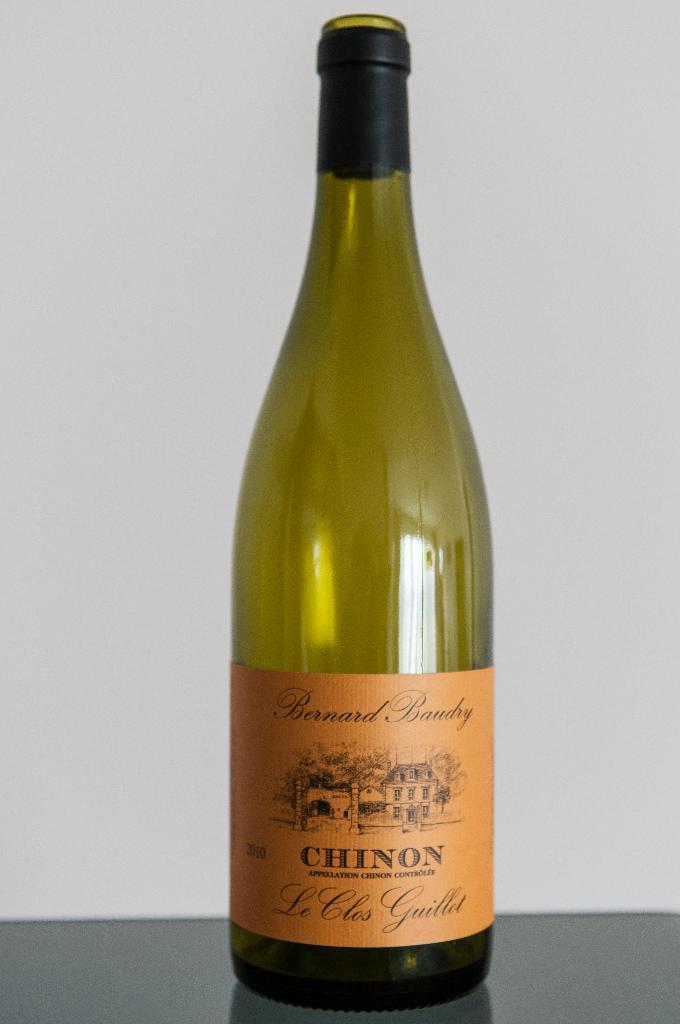What years vintage is this?
Provide a short and direct response. 2010. 